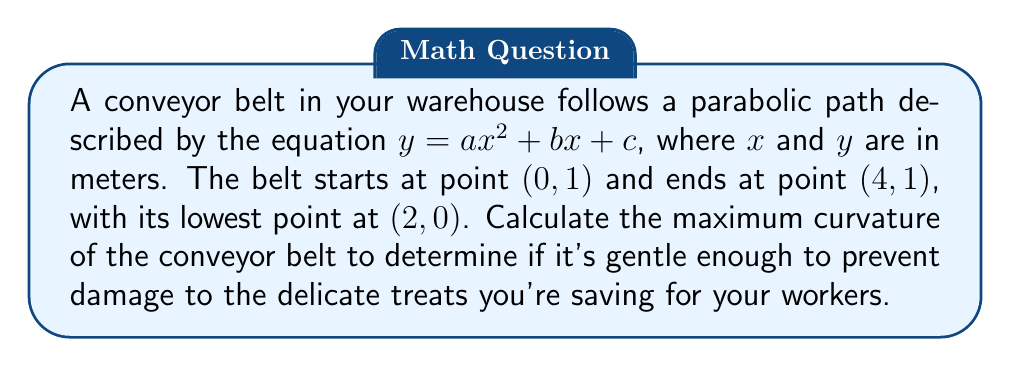Solve this math problem. Let's approach this step-by-step:

1) Given the points $(0, 1)$, $(4, 1)$, and $(2, 0)$, we can determine the coefficients $a$, $b$, and $c$:

   $y = ax^2 + bx + c$

2) Using the three points:
   $(0, 1)$: $1 = a(0)^2 + b(0) + c$, so $c = 1$
   $(4, 1)$: $1 = a(4)^2 + b(4) + 1$
   $(2, 0)$: $0 = a(2)^2 + b(2) + 1$

3) From the last equation:
   $0 = 4a + 2b + 1$
   $-1 = 4a + 2b$ ... (1)

4) Subtracting the first equation from the second:
   $0 = 16a + 4b$
   $0 = 4a + b$ ... (2)

5) From (2): $b = -4a$
   Substituting into (1):
   $-1 = 4a + 2(-4a) = -4a$
   $a = 1/4$

6) Therefore, the equation of the parabola is:
   $y = \frac{1}{4}x^2 - x + 1$

7) The curvature $\kappa$ of a curve $y=f(x)$ is given by:

   $$\kappa = \frac{|f''(x)|}{(1 + (f'(x))^2)^{3/2}}$$

8) For our parabola:
   $f'(x) = \frac{1}{2}x - 1$
   $f''(x) = \frac{1}{2}$

9) Substituting into the curvature formula:

   $$\kappa = \frac{|\frac{1}{2}|}{(1 + (\frac{1}{2}x - 1)^2)^{3/2}}$$

10) The maximum curvature occurs at the vertex of the parabola, where $x = 2$:

    $$\kappa_{max} = \frac{|\frac{1}{2}|}{(1 + (0)^2)^{3/2}} = \frac{1}{2}$$
Answer: $\frac{1}{2}$ m$^{-1}$ 